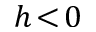<formula> <loc_0><loc_0><loc_500><loc_500>h \, < \, 0</formula> 